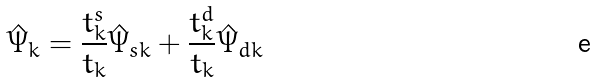Convert formula to latex. <formula><loc_0><loc_0><loc_500><loc_500>\hat { \Psi } _ { k } = \frac { t _ { k } ^ { s } } { t _ { k } } \hat { \Psi } _ { s k } + \frac { t _ { k } ^ { d } } { t _ { k } } \hat { \Psi } _ { d k }</formula> 